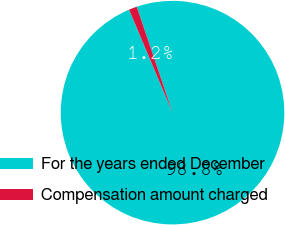<chart> <loc_0><loc_0><loc_500><loc_500><pie_chart><fcel>For the years ended December<fcel>Compensation amount charged<nl><fcel>98.83%<fcel>1.17%<nl></chart> 